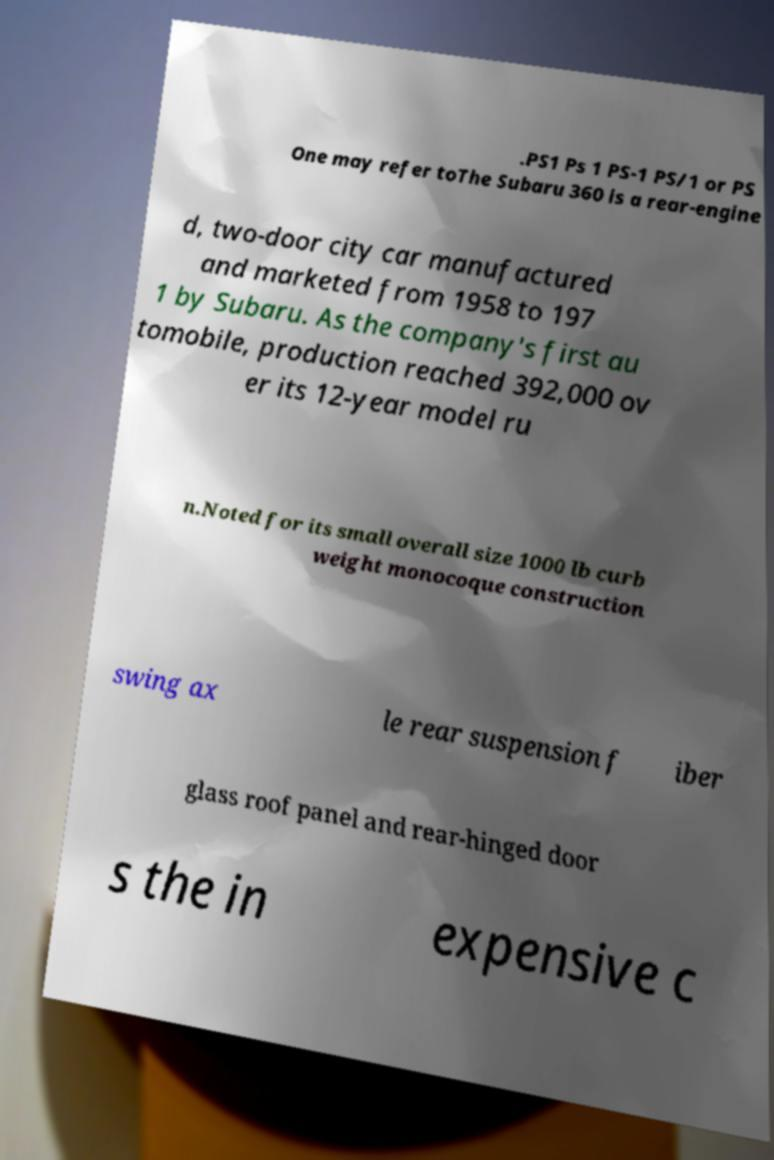Can you accurately transcribe the text from the provided image for me? .PS1 Ps 1 PS-1 PS/1 or PS One may refer toThe Subaru 360 is a rear-engine d, two-door city car manufactured and marketed from 1958 to 197 1 by Subaru. As the company's first au tomobile, production reached 392,000 ov er its 12-year model ru n.Noted for its small overall size 1000 lb curb weight monocoque construction swing ax le rear suspension f iber glass roof panel and rear-hinged door s the in expensive c 